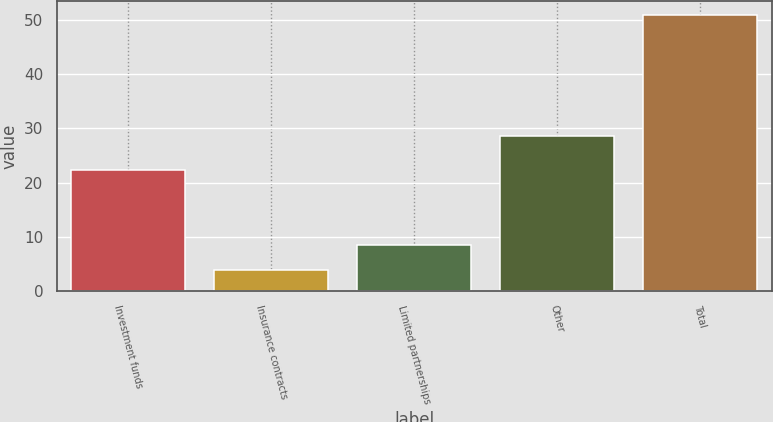Convert chart to OTSL. <chart><loc_0><loc_0><loc_500><loc_500><bar_chart><fcel>Investment funds<fcel>Insurance contracts<fcel>Limited partnerships<fcel>Other<fcel>Total<nl><fcel>22.3<fcel>3.85<fcel>8.55<fcel>28.6<fcel>50.9<nl></chart> 